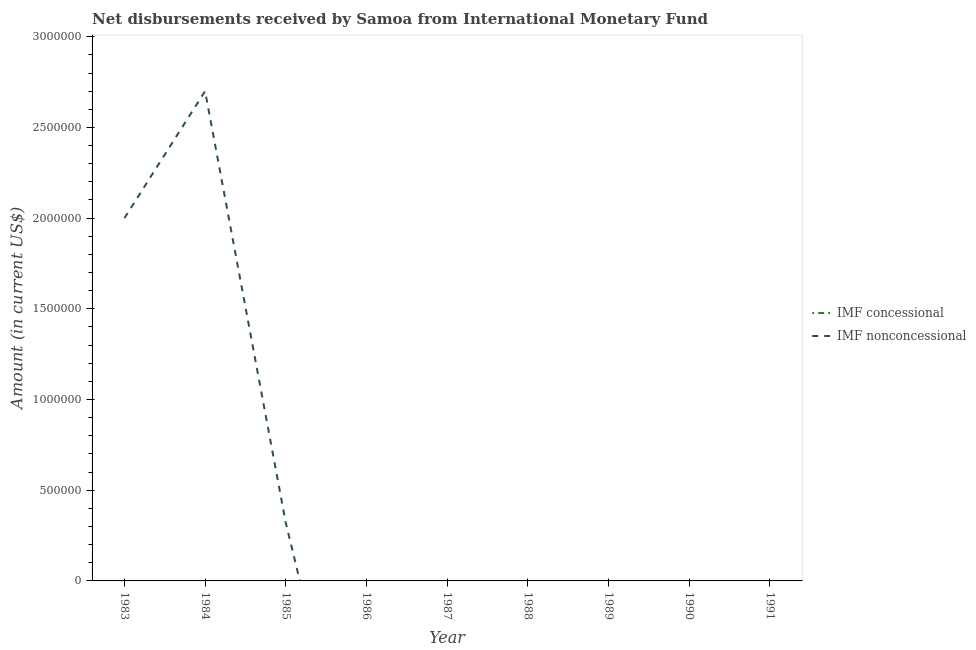Does the line corresponding to net non concessional disbursements from imf intersect with the line corresponding to net concessional disbursements from imf?
Make the answer very short. Yes. Across all years, what is the maximum net non concessional disbursements from imf?
Keep it short and to the point. 2.70e+06. What is the total net non concessional disbursements from imf in the graph?
Your answer should be very brief. 5.02e+06. What is the difference between the net non concessional disbursements from imf in 1984 and that in 1985?
Give a very brief answer. 2.38e+06. What is the difference between the net concessional disbursements from imf in 1990 and the net non concessional disbursements from imf in 1984?
Keep it short and to the point. -2.70e+06. What is the average net non concessional disbursements from imf per year?
Your response must be concise. 5.58e+05. In how many years, is the net concessional disbursements from imf greater than 700000 US$?
Offer a very short reply. 0. What is the ratio of the net non concessional disbursements from imf in 1984 to that in 1985?
Provide a short and direct response. 8.44. What is the difference between the highest and the second highest net non concessional disbursements from imf?
Your response must be concise. 7.00e+05. What is the difference between the highest and the lowest net non concessional disbursements from imf?
Keep it short and to the point. 2.70e+06. In how many years, is the net concessional disbursements from imf greater than the average net concessional disbursements from imf taken over all years?
Make the answer very short. 0. Is the net concessional disbursements from imf strictly greater than the net non concessional disbursements from imf over the years?
Give a very brief answer. No. Is the net non concessional disbursements from imf strictly less than the net concessional disbursements from imf over the years?
Offer a very short reply. No. How many lines are there?
Make the answer very short. 1. What is the difference between two consecutive major ticks on the Y-axis?
Make the answer very short. 5.00e+05. Are the values on the major ticks of Y-axis written in scientific E-notation?
Offer a terse response. No. Does the graph contain grids?
Keep it short and to the point. No. Where does the legend appear in the graph?
Ensure brevity in your answer.  Center right. How many legend labels are there?
Your response must be concise. 2. What is the title of the graph?
Your answer should be compact. Net disbursements received by Samoa from International Monetary Fund. What is the label or title of the X-axis?
Give a very brief answer. Year. What is the label or title of the Y-axis?
Your response must be concise. Amount (in current US$). What is the Amount (in current US$) of IMF nonconcessional in 1984?
Offer a very short reply. 2.70e+06. What is the Amount (in current US$) of IMF nonconcessional in 1985?
Provide a succinct answer. 3.20e+05. What is the Amount (in current US$) in IMF concessional in 1986?
Ensure brevity in your answer.  0. What is the Amount (in current US$) of IMF nonconcessional in 1986?
Provide a short and direct response. 0. What is the Amount (in current US$) in IMF concessional in 1988?
Ensure brevity in your answer.  0. What is the Amount (in current US$) in IMF concessional in 1991?
Offer a very short reply. 0. What is the Amount (in current US$) in IMF nonconcessional in 1991?
Offer a very short reply. 0. Across all years, what is the maximum Amount (in current US$) in IMF nonconcessional?
Make the answer very short. 2.70e+06. What is the total Amount (in current US$) of IMF nonconcessional in the graph?
Ensure brevity in your answer.  5.02e+06. What is the difference between the Amount (in current US$) of IMF nonconcessional in 1983 and that in 1984?
Offer a very short reply. -7.00e+05. What is the difference between the Amount (in current US$) in IMF nonconcessional in 1983 and that in 1985?
Offer a very short reply. 1.68e+06. What is the difference between the Amount (in current US$) in IMF nonconcessional in 1984 and that in 1985?
Make the answer very short. 2.38e+06. What is the average Amount (in current US$) in IMF concessional per year?
Keep it short and to the point. 0. What is the average Amount (in current US$) in IMF nonconcessional per year?
Offer a terse response. 5.58e+05. What is the ratio of the Amount (in current US$) of IMF nonconcessional in 1983 to that in 1984?
Offer a very short reply. 0.74. What is the ratio of the Amount (in current US$) in IMF nonconcessional in 1983 to that in 1985?
Your answer should be compact. 6.25. What is the ratio of the Amount (in current US$) in IMF nonconcessional in 1984 to that in 1985?
Ensure brevity in your answer.  8.44. What is the difference between the highest and the second highest Amount (in current US$) in IMF nonconcessional?
Ensure brevity in your answer.  7.00e+05. What is the difference between the highest and the lowest Amount (in current US$) of IMF nonconcessional?
Provide a succinct answer. 2.70e+06. 